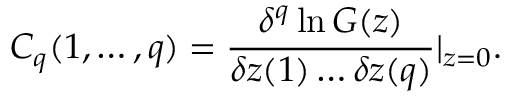<formula> <loc_0><loc_0><loc_500><loc_500>C _ { q } ( 1 , \dots , q ) = { \frac { \delta ^ { q } \ln G ( z ) } { \delta z ( 1 ) \dots \delta z ( q ) } } | _ { z = 0 } .</formula> 